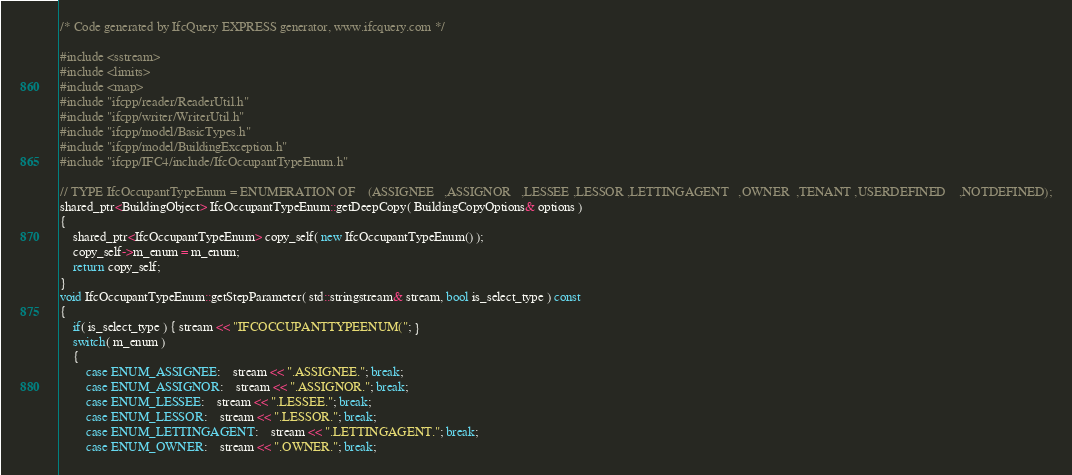<code> <loc_0><loc_0><loc_500><loc_500><_C++_>/* Code generated by IfcQuery EXPRESS generator, www.ifcquery.com */

#include <sstream>
#include <limits>
#include <map>
#include "ifcpp/reader/ReaderUtil.h"
#include "ifcpp/writer/WriterUtil.h"
#include "ifcpp/model/BasicTypes.h"
#include "ifcpp/model/BuildingException.h"
#include "ifcpp/IFC4/include/IfcOccupantTypeEnum.h"

// TYPE IfcOccupantTypeEnum = ENUMERATION OF	(ASSIGNEE	,ASSIGNOR	,LESSEE	,LESSOR	,LETTINGAGENT	,OWNER	,TENANT	,USERDEFINED	,NOTDEFINED);
shared_ptr<BuildingObject> IfcOccupantTypeEnum::getDeepCopy( BuildingCopyOptions& options )
{
	shared_ptr<IfcOccupantTypeEnum> copy_self( new IfcOccupantTypeEnum() );
	copy_self->m_enum = m_enum;
	return copy_self;
}
void IfcOccupantTypeEnum::getStepParameter( std::stringstream& stream, bool is_select_type ) const
{
	if( is_select_type ) { stream << "IFCOCCUPANTTYPEENUM("; }
	switch( m_enum )
	{
		case ENUM_ASSIGNEE:	stream << ".ASSIGNEE."; break;
		case ENUM_ASSIGNOR:	stream << ".ASSIGNOR."; break;
		case ENUM_LESSEE:	stream << ".LESSEE."; break;
		case ENUM_LESSOR:	stream << ".LESSOR."; break;
		case ENUM_LETTINGAGENT:	stream << ".LETTINGAGENT."; break;
		case ENUM_OWNER:	stream << ".OWNER."; break;</code> 